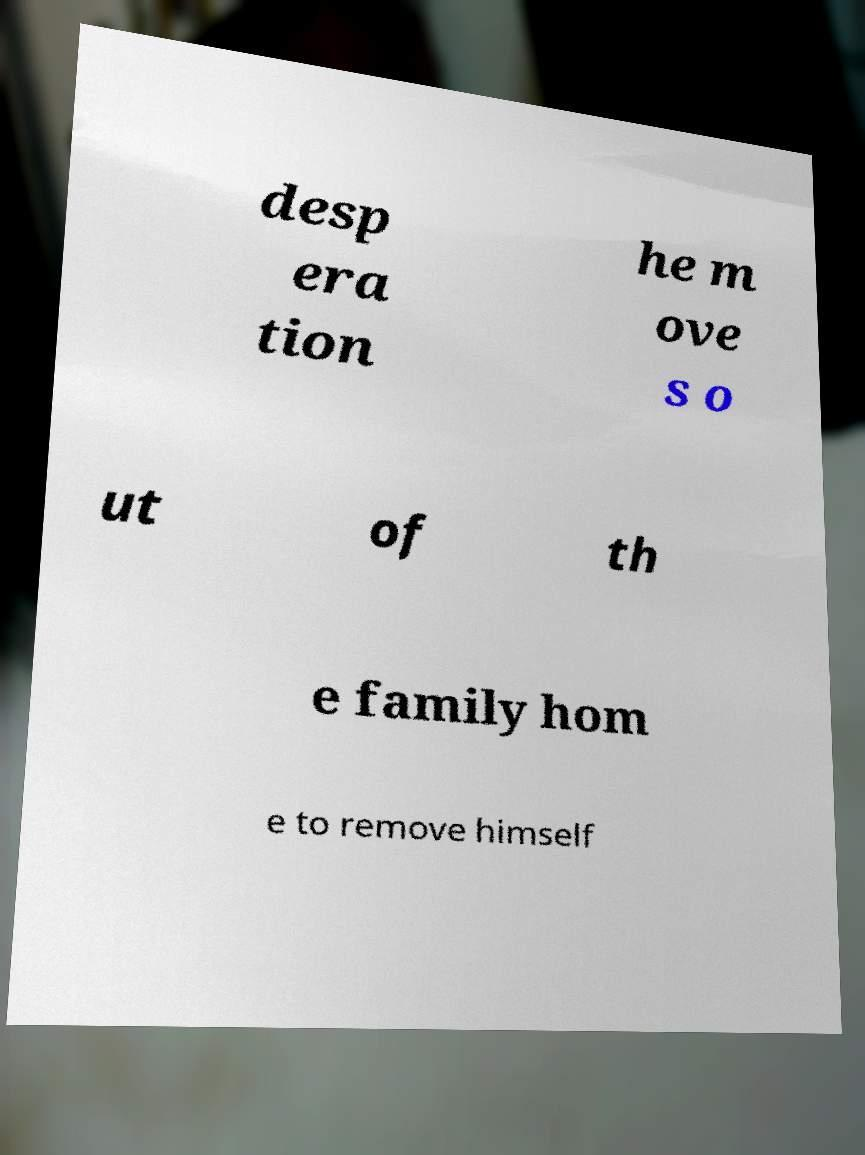Please read and relay the text visible in this image. What does it say? desp era tion he m ove s o ut of th e family hom e to remove himself 